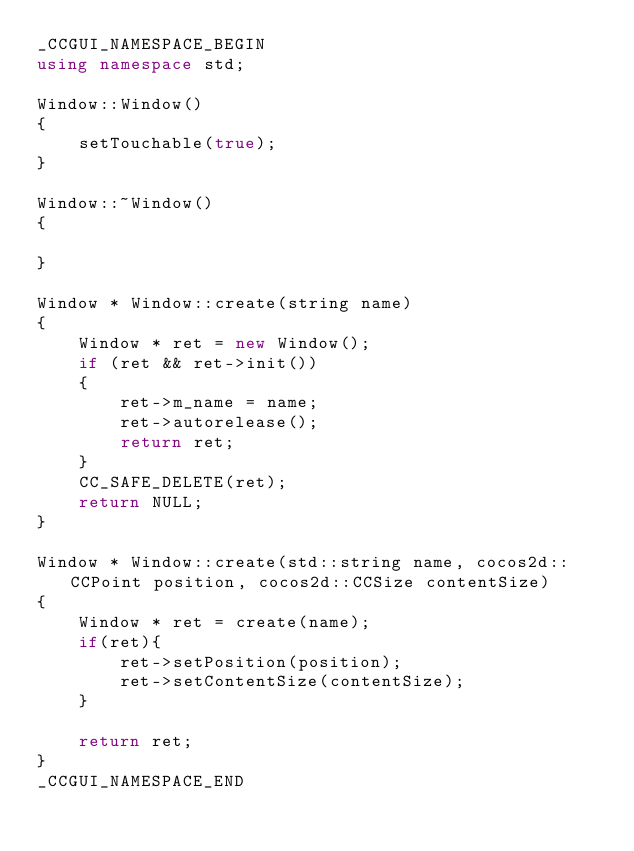Convert code to text. <code><loc_0><loc_0><loc_500><loc_500><_C++_>_CCGUI_NAMESPACE_BEGIN
using namespace std;

Window::Window()
{
    setTouchable(true);
}

Window::~Window()
{
    
}

Window * Window::create(string name)
{
    Window * ret = new Window();
    if (ret && ret->init())
    {
        ret->m_name = name;
        ret->autorelease();
        return ret;
    }
    CC_SAFE_DELETE(ret);
    return NULL;
}

Window * Window::create(std::string name, cocos2d::CCPoint position, cocos2d::CCSize contentSize)
{
    Window * ret = create(name);
    if(ret){
        ret->setPosition(position);
        ret->setContentSize(contentSize);
    }
    
    return ret;
}
_CCGUI_NAMESPACE_END








</code> 